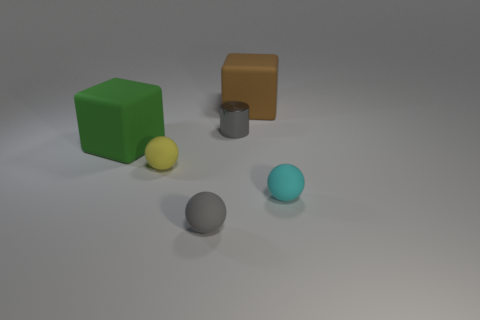Subtract all small cyan rubber balls. How many balls are left? 2 Subtract 1 spheres. How many spheres are left? 2 Add 1 purple shiny spheres. How many objects exist? 7 Subtract all cubes. How many objects are left? 4 Add 5 cyan objects. How many cyan objects exist? 6 Subtract 0 cyan cubes. How many objects are left? 6 Subtract all brown spheres. Subtract all cyan cubes. How many spheres are left? 3 Subtract all small gray matte spheres. Subtract all small yellow rubber balls. How many objects are left? 4 Add 2 large cubes. How many large cubes are left? 4 